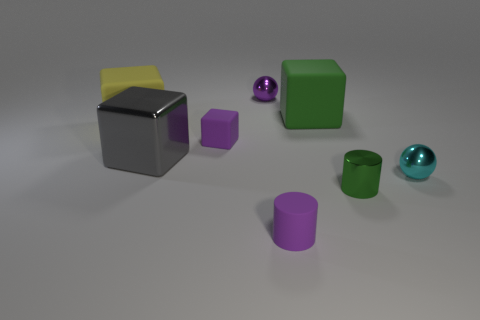Subtract 1 cubes. How many cubes are left? 3 Subtract all blue cubes. Subtract all cyan balls. How many cubes are left? 4 Add 1 large yellow metallic cylinders. How many objects exist? 9 Subtract all cylinders. How many objects are left? 6 Subtract 1 purple cylinders. How many objects are left? 7 Subtract all large gray balls. Subtract all purple spheres. How many objects are left? 7 Add 2 tiny cyan metallic things. How many tiny cyan metallic things are left? 3 Add 6 big yellow shiny spheres. How many big yellow shiny spheres exist? 6 